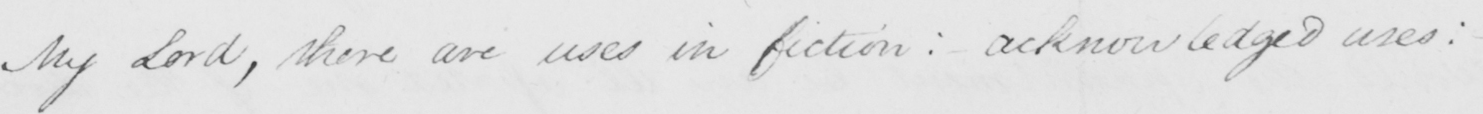Can you tell me what this handwritten text says? My Lord , there are uses in fiction :  acknowledged uses :   _ 